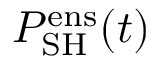<formula> <loc_0><loc_0><loc_500><loc_500>P _ { S H } ^ { e n s } ( t )</formula> 